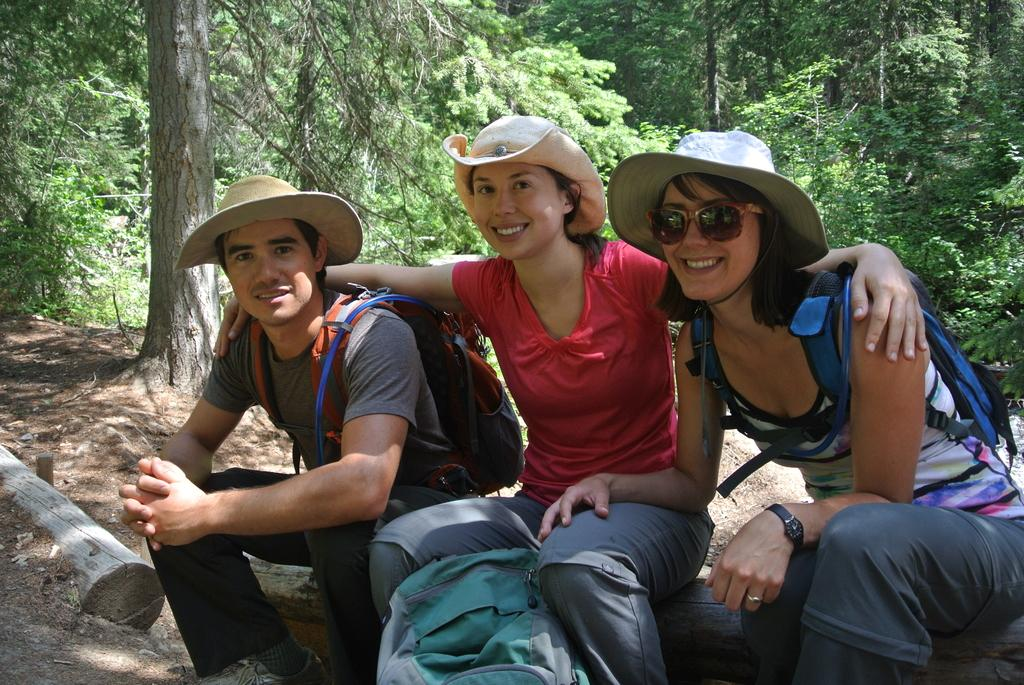What objects can be seen in the image? There are bags in the image. What are the people wearing on their heads? Three people are wearing hats. Where are the people sitting? The people are sitting on a wooden log. What is the facial expression of the people? The people are smiling. What can be seen in the background of the image? There are trees in the background of the image. What type of pin can be seen holding the bags together in the image? There is no pin visible in the image holding the bags together. Is there a wheel present in the image? There is no wheel present in the image. 